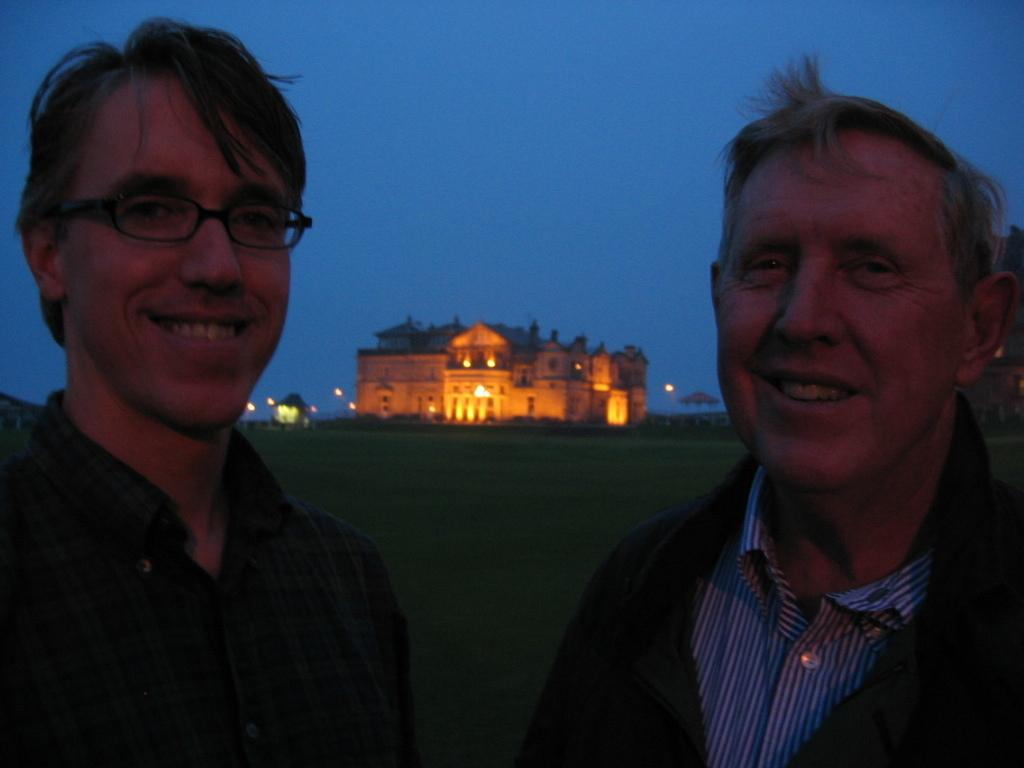How many people are in the image? There are two men in the image. What expressions do the men have? The men are smiling. What type of terrain is visible in the image? There is grass visible in the image. What can be seen in the background of the image? There is a building, lights, and the sky visible in the background of the image. What type of sea creature can be seen swimming in the image? There is no sea creature present in the image; it features two men smiling in a grassy area with a building and sky in the background. 